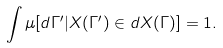<formula> <loc_0><loc_0><loc_500><loc_500>\int \mu [ d \Gamma ^ { \prime } | X ( \Gamma ^ { \prime } ) \in d X ( \Gamma ) ] = 1 .</formula> 